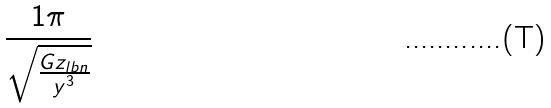<formula> <loc_0><loc_0><loc_500><loc_500>\frac { 1 \pi } { \sqrt { \frac { G z _ { l b n } } { y ^ { 3 } } } }</formula> 